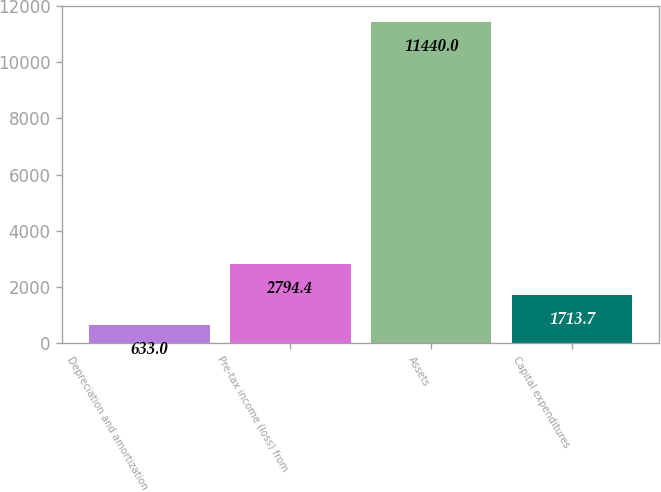Convert chart to OTSL. <chart><loc_0><loc_0><loc_500><loc_500><bar_chart><fcel>Depreciation and amortization<fcel>Pre-tax income (loss) from<fcel>Assets<fcel>Capital expenditures<nl><fcel>633<fcel>2794.4<fcel>11440<fcel>1713.7<nl></chart> 